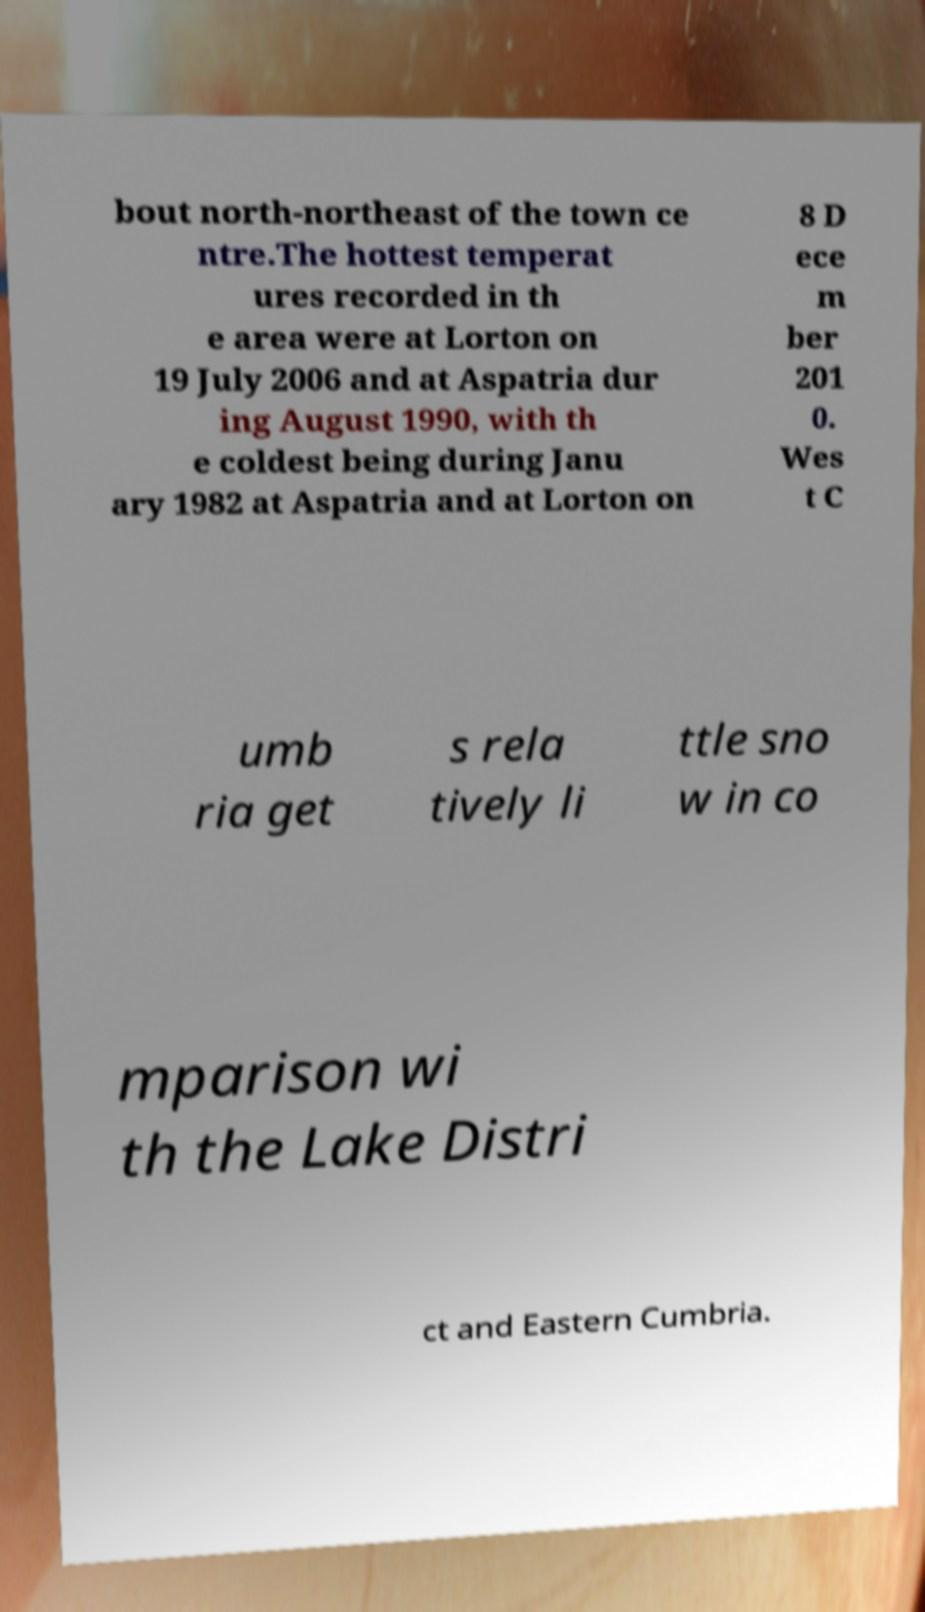Can you accurately transcribe the text from the provided image for me? bout north-northeast of the town ce ntre.The hottest temperat ures recorded in th e area were at Lorton on 19 July 2006 and at Aspatria dur ing August 1990, with th e coldest being during Janu ary 1982 at Aspatria and at Lorton on 8 D ece m ber 201 0. Wes t C umb ria get s rela tively li ttle sno w in co mparison wi th the Lake Distri ct and Eastern Cumbria. 